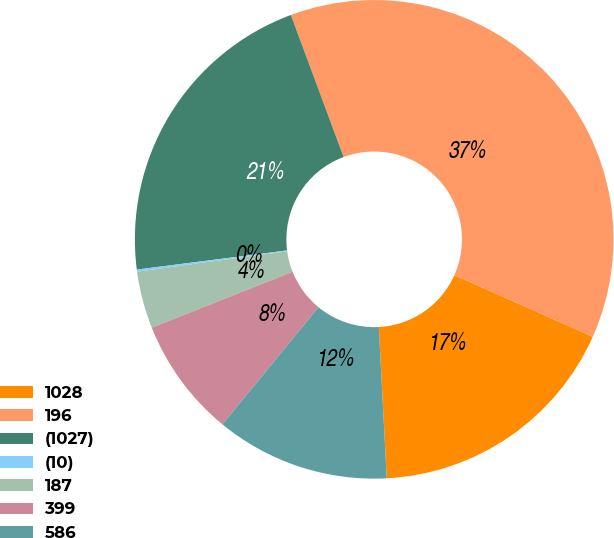Convert chart. <chart><loc_0><loc_0><loc_500><loc_500><pie_chart><fcel>1028<fcel>196<fcel>(1027)<fcel>(10)<fcel>187<fcel>399<fcel>586<nl><fcel>17.49%<fcel>37.34%<fcel>21.36%<fcel>0.14%<fcel>3.86%<fcel>8.05%<fcel>11.77%<nl></chart> 